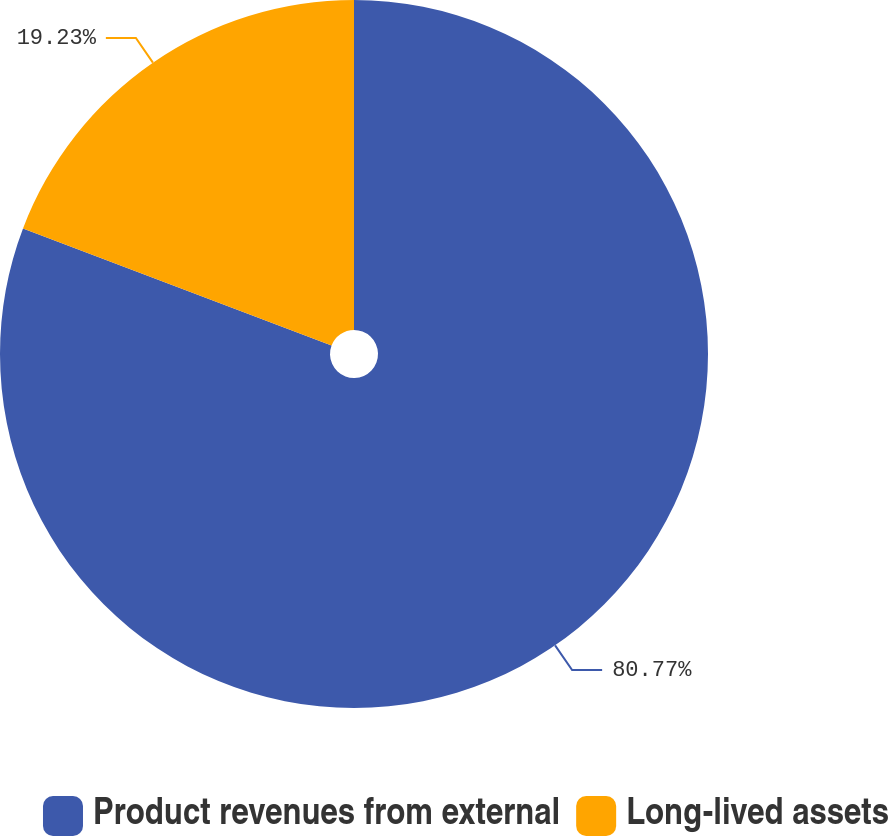<chart> <loc_0><loc_0><loc_500><loc_500><pie_chart><fcel>Product revenues from external<fcel>Long-lived assets<nl><fcel>80.77%<fcel>19.23%<nl></chart> 